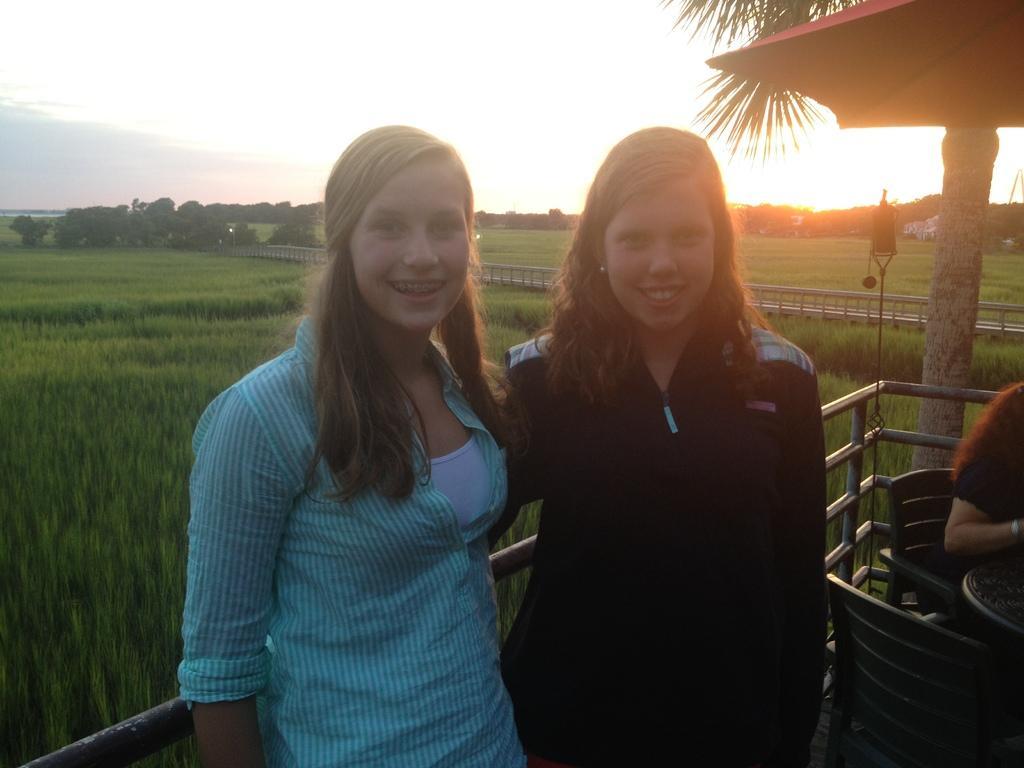Can you describe this image briefly? In this image we can see two lady persons different colors of dress hugging each other standing near the fencing and at the background of the image there are some trees, open land and clear sky. 